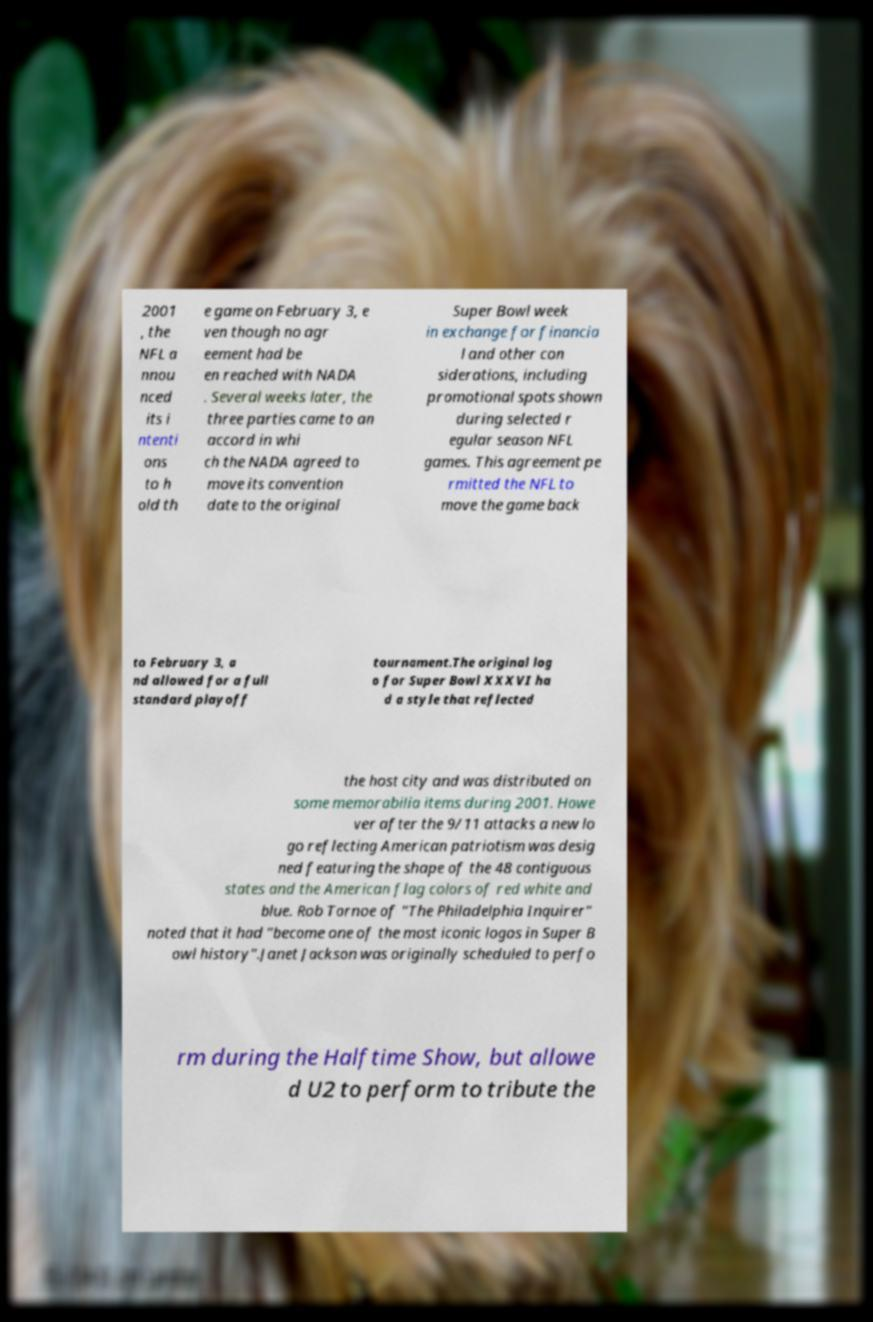Can you accurately transcribe the text from the provided image for me? 2001 , the NFL a nnou nced its i ntenti ons to h old th e game on February 3, e ven though no agr eement had be en reached with NADA . Several weeks later, the three parties came to an accord in whi ch the NADA agreed to move its convention date to the original Super Bowl week in exchange for financia l and other con siderations, including promotional spots shown during selected r egular season NFL games. This agreement pe rmitted the NFL to move the game back to February 3, a nd allowed for a full standard playoff tournament.The original log o for Super Bowl XXXVI ha d a style that reflected the host city and was distributed on some memorabilia items during 2001. Howe ver after the 9/11 attacks a new lo go reflecting American patriotism was desig ned featuring the shape of the 48 contiguous states and the American flag colors of red white and blue. Rob Tornoe of "The Philadelphia Inquirer" noted that it had "become one of the most iconic logos in Super B owl history".Janet Jackson was originally scheduled to perfo rm during the Halftime Show, but allowe d U2 to perform to tribute the 